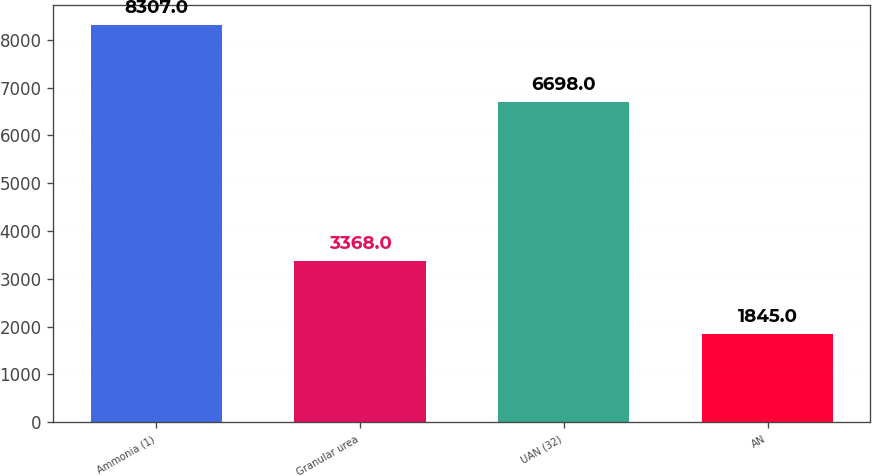Convert chart to OTSL. <chart><loc_0><loc_0><loc_500><loc_500><bar_chart><fcel>Ammonia (1)<fcel>Granular urea<fcel>UAN (32)<fcel>AN<nl><fcel>8307<fcel>3368<fcel>6698<fcel>1845<nl></chart> 